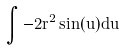<formula> <loc_0><loc_0><loc_500><loc_500>\int - 2 r ^ { 2 } \sin ( u ) d u</formula> 